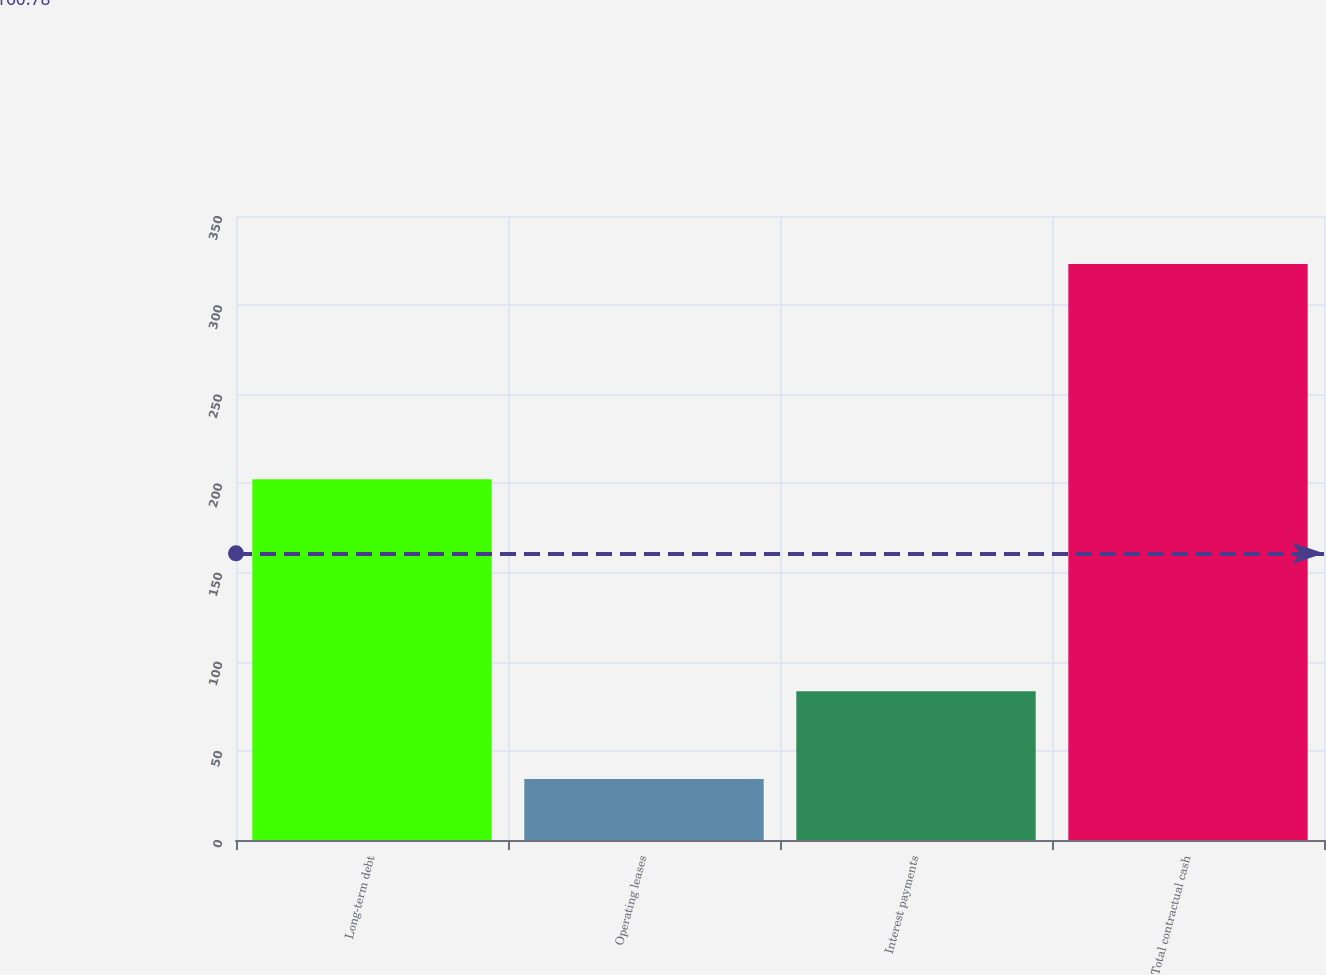<chart> <loc_0><loc_0><loc_500><loc_500><bar_chart><fcel>Long-term debt<fcel>Operating leases<fcel>Interest payments<fcel>Total contractual cash<nl><fcel>202.3<fcel>34.2<fcel>83.5<fcel>323.1<nl></chart> 